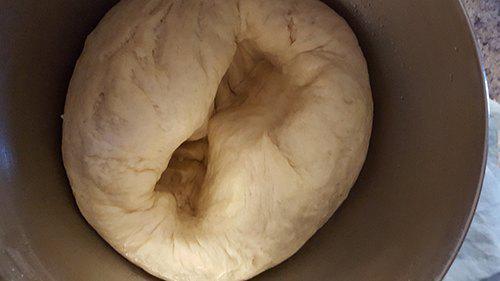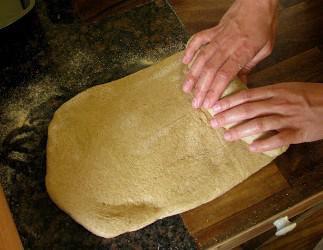The first image is the image on the left, the second image is the image on the right. For the images shown, is this caption "There are no wooden utensils present." true? Answer yes or no. Yes. The first image is the image on the left, the second image is the image on the right. Examine the images to the left and right. Is the description "The right image shows a pair of hands with fingers touching flattened dough on floured wood," accurate? Answer yes or no. Yes. 